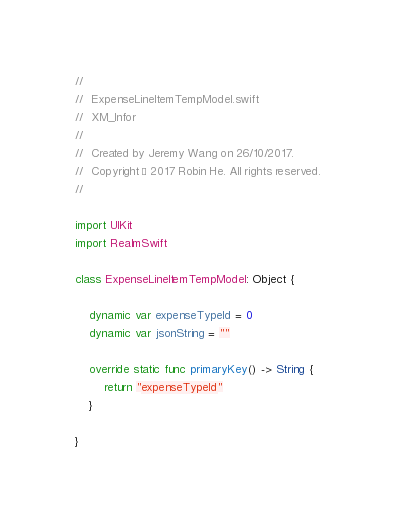<code> <loc_0><loc_0><loc_500><loc_500><_Swift_>//
//  ExpenseLineItemTempModel.swift
//  XM_Infor
//
//  Created by Jeremy Wang on 26/10/2017.
//  Copyright © 2017 Robin He. All rights reserved.
//

import UIKit
import RealmSwift

class ExpenseLineItemTempModel: Object {
    
    dynamic var expenseTypeId = 0
    dynamic var jsonString = ""
    
    override static func primaryKey() -> String {
        return "expenseTypeId"
    }
    
}
</code> 